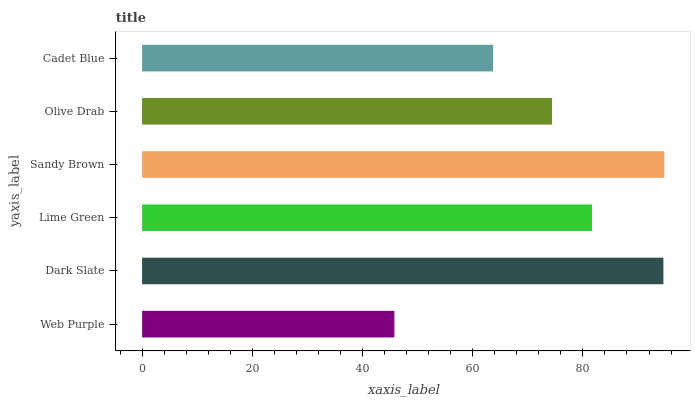Is Web Purple the minimum?
Answer yes or no. Yes. Is Sandy Brown the maximum?
Answer yes or no. Yes. Is Dark Slate the minimum?
Answer yes or no. No. Is Dark Slate the maximum?
Answer yes or no. No. Is Dark Slate greater than Web Purple?
Answer yes or no. Yes. Is Web Purple less than Dark Slate?
Answer yes or no. Yes. Is Web Purple greater than Dark Slate?
Answer yes or no. No. Is Dark Slate less than Web Purple?
Answer yes or no. No. Is Lime Green the high median?
Answer yes or no. Yes. Is Olive Drab the low median?
Answer yes or no. Yes. Is Dark Slate the high median?
Answer yes or no. No. Is Dark Slate the low median?
Answer yes or no. No. 